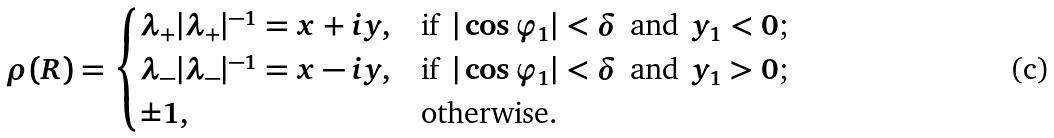<formula> <loc_0><loc_0><loc_500><loc_500>\rho ( R ) = \begin{cases} \lambda _ { + } | \lambda _ { + } | ^ { - 1 } = x + i y , & \text {if $\,|\cos\varphi_{1}|<\delta\,$ and $\,y_{1}<0$;} \\ \lambda _ { - } | \lambda _ { - } | ^ { - 1 } = x - i y , & \text {if $\,|\cos\varphi_{1}|<\delta\,$ and $\,y_{1}>0$;} \\ \pm 1 , & \text {otherwise.} \end{cases}</formula> 